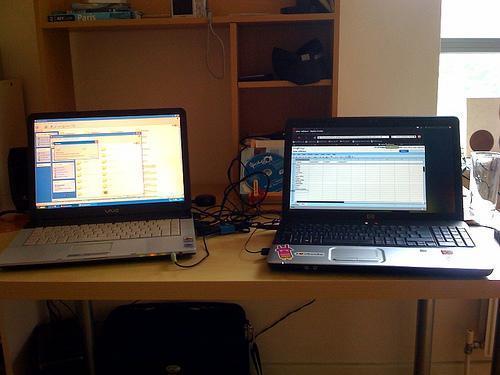How many laptops in the photo?
Give a very brief answer. 2. How many monitors are there?
Give a very brief answer. 2. How many cups are in the photo?
Give a very brief answer. 1. How many keyboards are there?
Give a very brief answer. 2. How many laptops are in the picture?
Give a very brief answer. 2. 